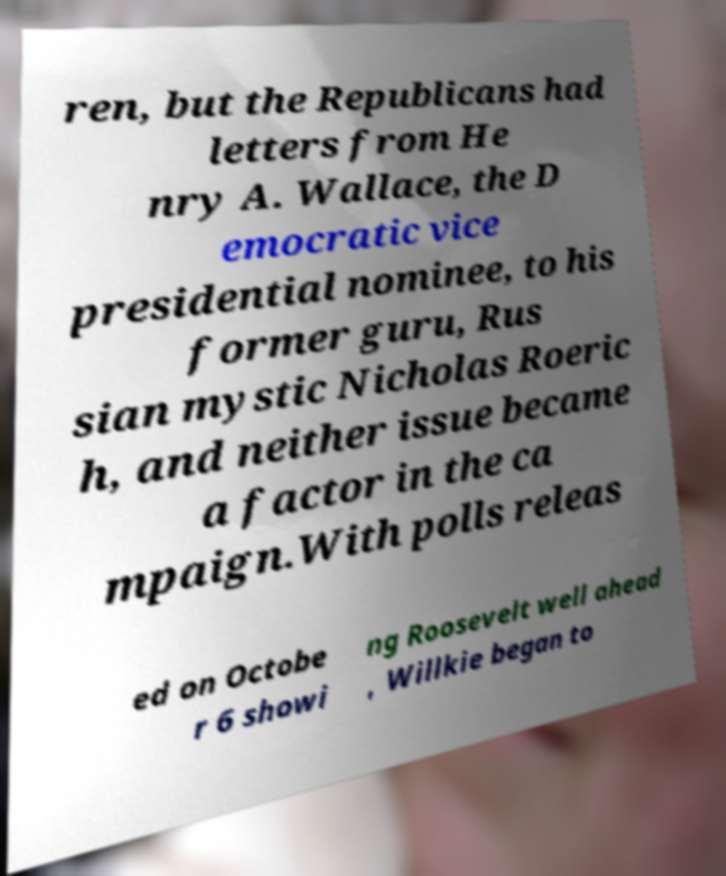For documentation purposes, I need the text within this image transcribed. Could you provide that? ren, but the Republicans had letters from He nry A. Wallace, the D emocratic vice presidential nominee, to his former guru, Rus sian mystic Nicholas Roeric h, and neither issue became a factor in the ca mpaign.With polls releas ed on Octobe r 6 showi ng Roosevelt well ahead , Willkie began to 